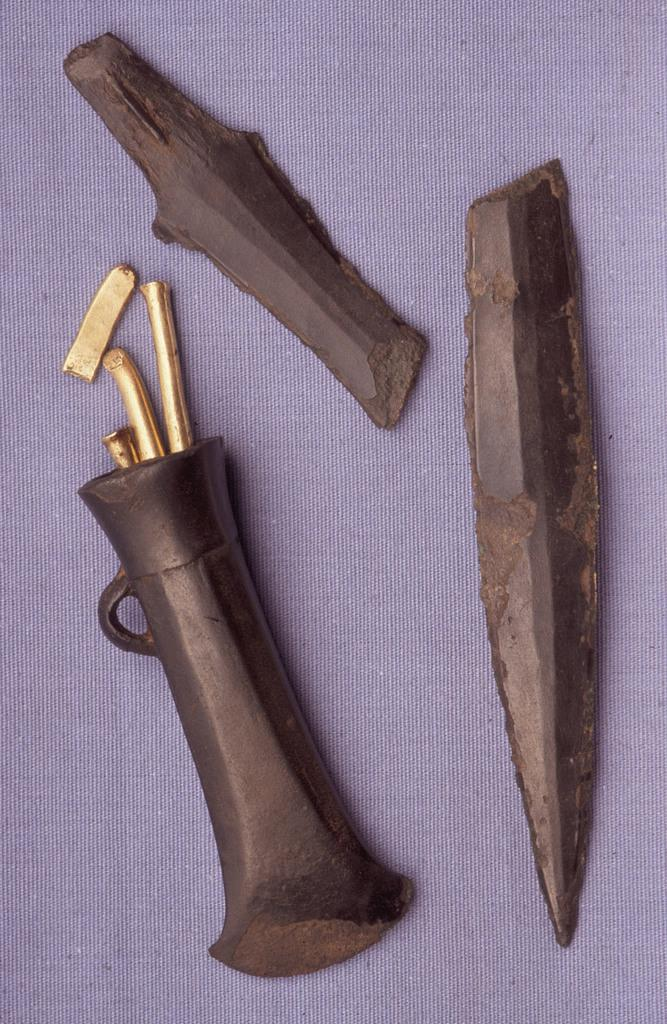What type of object can be seen in the image? There is a knife in the image. What material are the objects made of? The objects are made of metal. What color is the surface on which the objects are placed? The objects are placed on a violet surface. What type of root can be seen growing on the knife in the image? There is no root growing on the knife in the image. Is the boy wearing a winter coat in the image? There is no boy present in the image. 